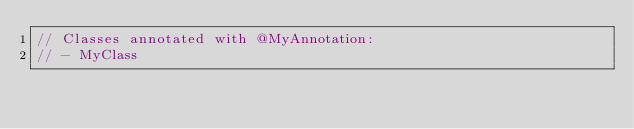Convert code to text. <code><loc_0><loc_0><loc_500><loc_500><_Dart_>// Classes annotated with @MyAnnotation:
// - MyClass
</code> 